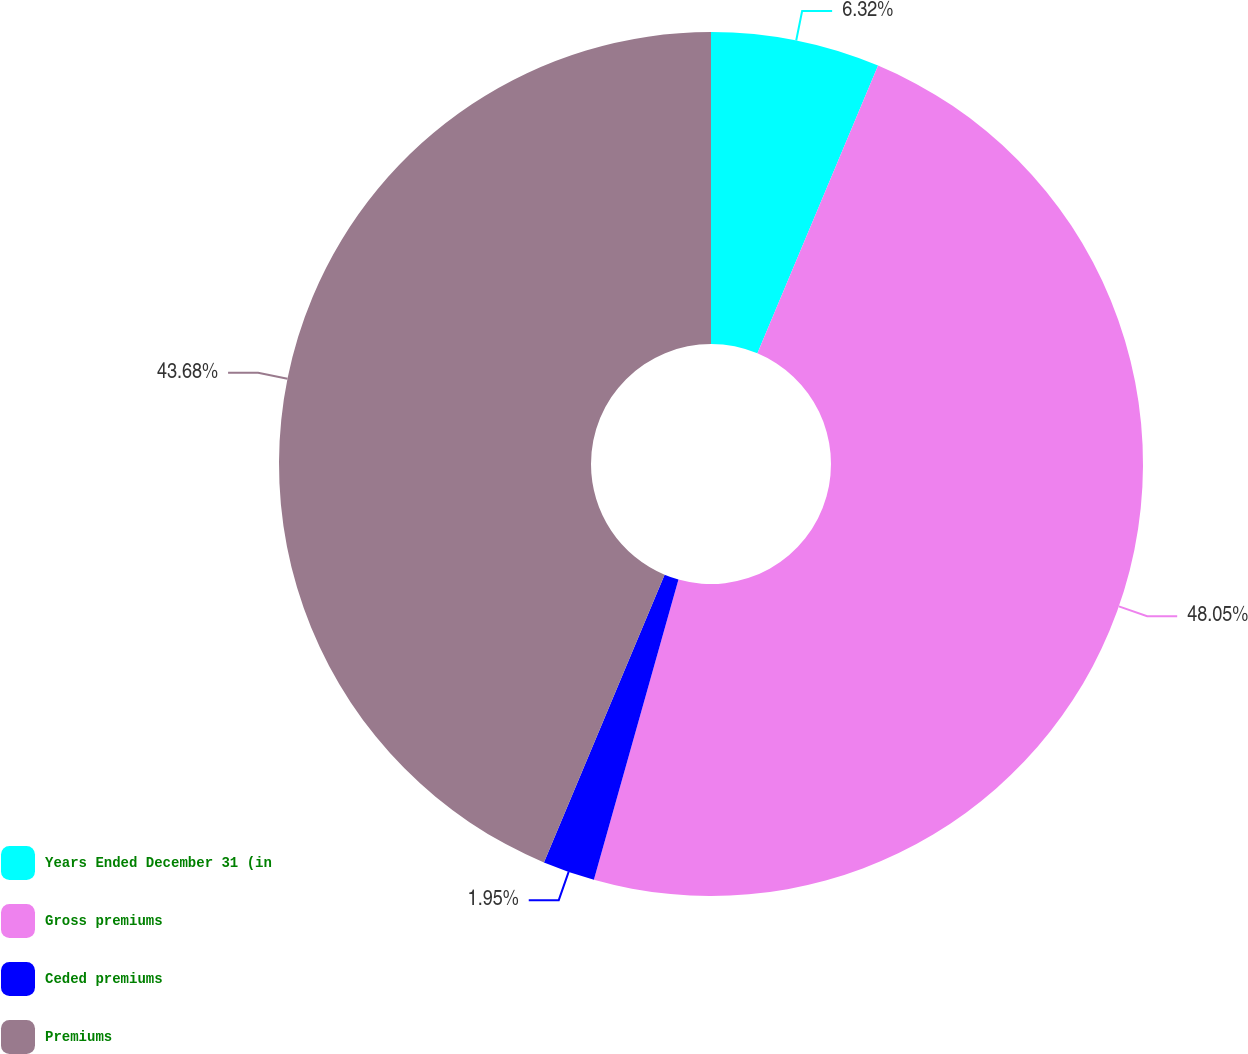<chart> <loc_0><loc_0><loc_500><loc_500><pie_chart><fcel>Years Ended December 31 (in<fcel>Gross premiums<fcel>Ceded premiums<fcel>Premiums<nl><fcel>6.32%<fcel>48.05%<fcel>1.95%<fcel>43.68%<nl></chart> 